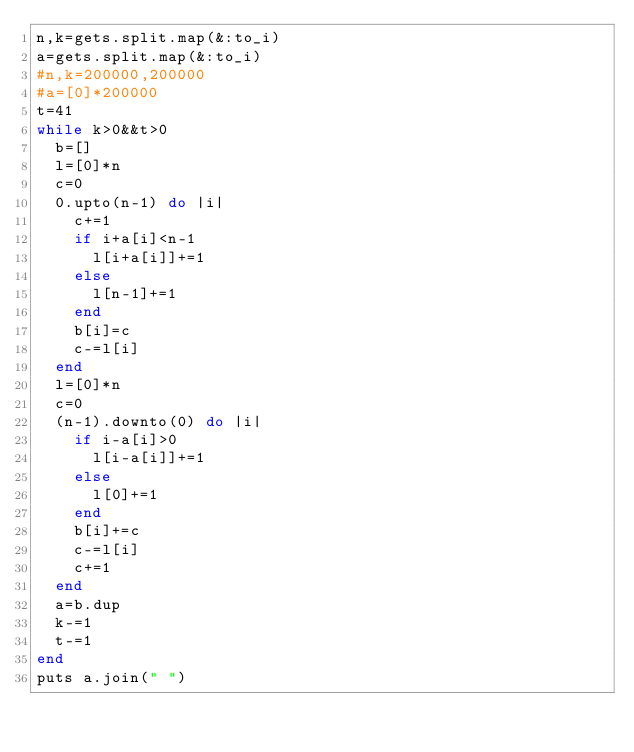<code> <loc_0><loc_0><loc_500><loc_500><_Ruby_>n,k=gets.split.map(&:to_i)
a=gets.split.map(&:to_i)
#n,k=200000,200000
#a=[0]*200000
t=41
while k>0&&t>0
  b=[]
  l=[0]*n
  c=0
  0.upto(n-1) do |i|
    c+=1
    if i+a[i]<n-1
      l[i+a[i]]+=1
    else
      l[n-1]+=1
    end
    b[i]=c
    c-=l[i]
  end
  l=[0]*n
  c=0
  (n-1).downto(0) do |i|
    if i-a[i]>0
      l[i-a[i]]+=1
    else
      l[0]+=1
    end
    b[i]+=c
    c-=l[i]
    c+=1
  end
  a=b.dup
  k-=1
  t-=1
end
puts a.join(" ")
</code> 